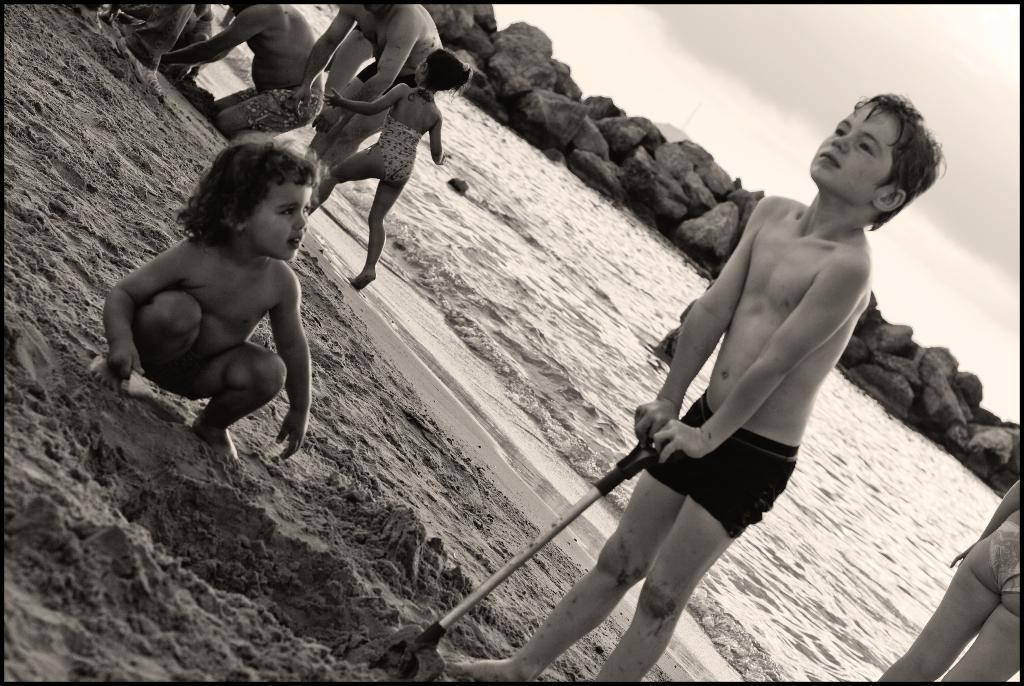In one or two sentences, can you explain what this image depicts? In this image I can see some kids are playing in the sand. In the background, I can see the water and big stones. I can see clouds in the sky. 